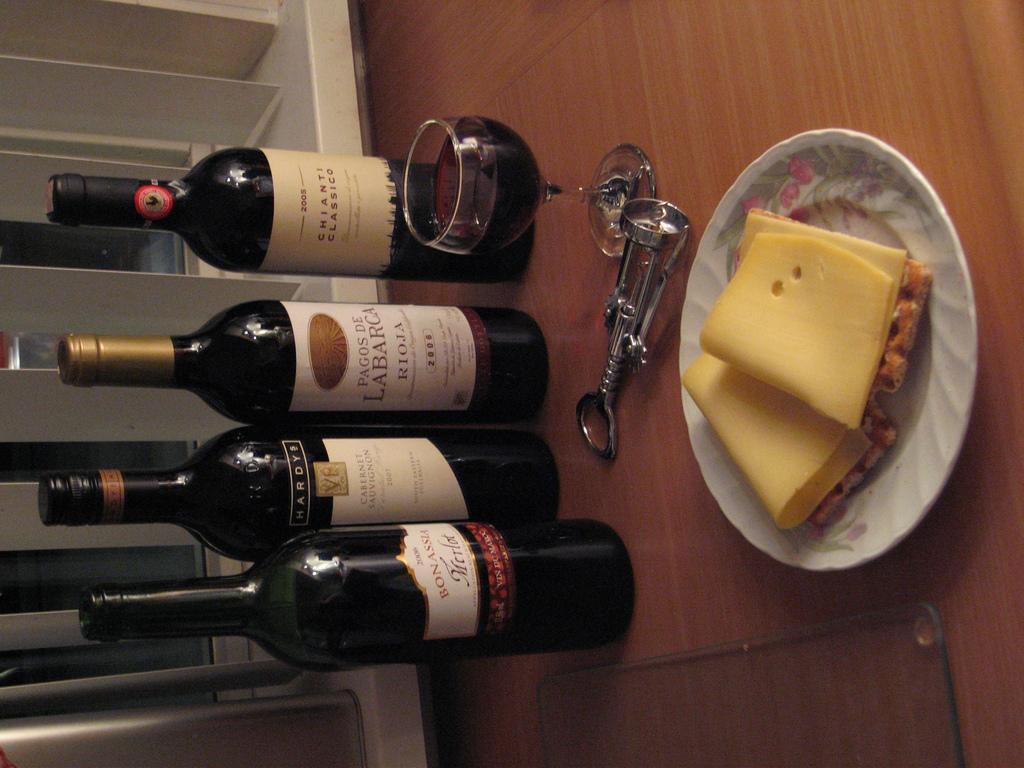Describe this image in one or two sentences. In this image I can see the wine bottles with stickers. In-front of the bottles I can see the glass, cork opener and the plate with food. These are on the brown color surface. 